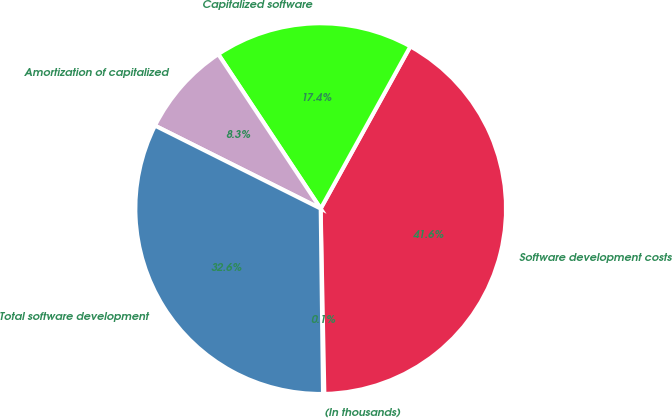Convert chart to OTSL. <chart><loc_0><loc_0><loc_500><loc_500><pie_chart><fcel>(In thousands)<fcel>Software development costs<fcel>Capitalized software<fcel>Amortization of capitalized<fcel>Total software development<nl><fcel>0.12%<fcel>41.65%<fcel>17.36%<fcel>8.29%<fcel>32.59%<nl></chart> 